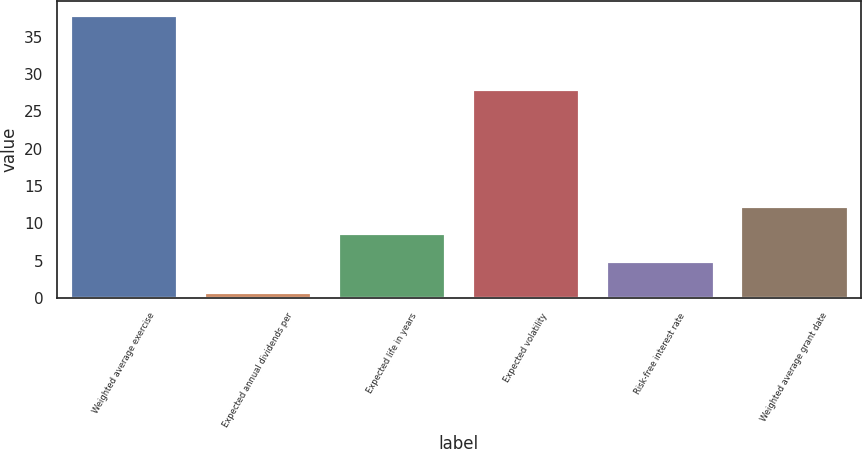Convert chart to OTSL. <chart><loc_0><loc_0><loc_500><loc_500><bar_chart><fcel>Weighted average exercise<fcel>Expected annual dividends per<fcel>Expected life in years<fcel>Expected volatility<fcel>Risk-free interest rate<fcel>Weighted average grant date<nl><fcel>37.84<fcel>0.8<fcel>8.7<fcel>28<fcel>5<fcel>12.4<nl></chart> 